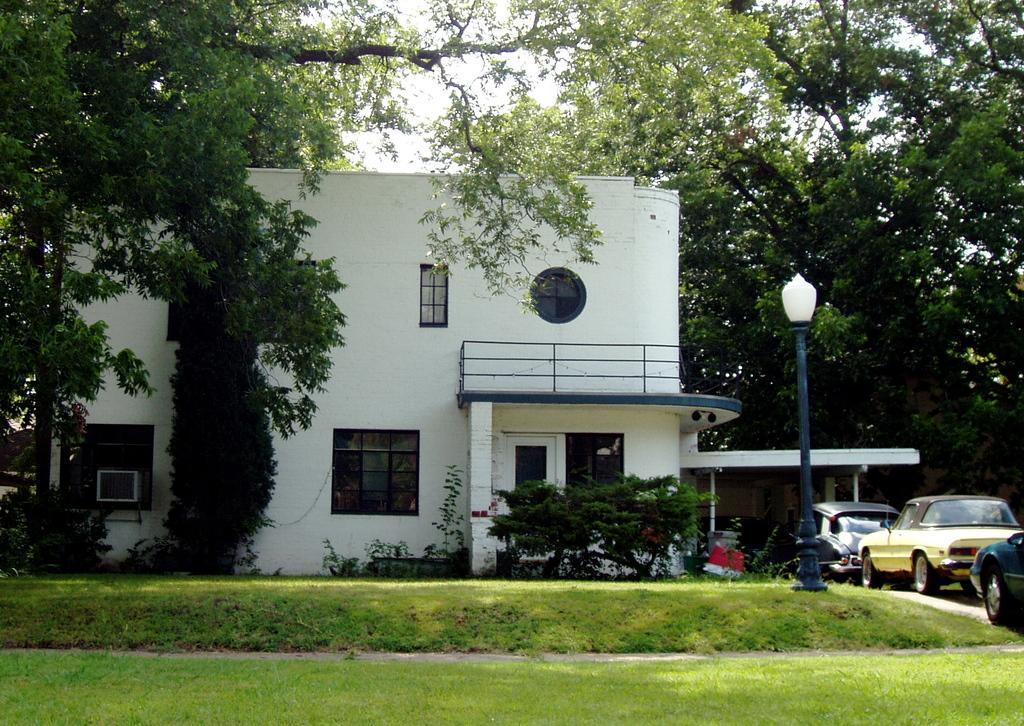Please provide a concise description of this image. In this image I can see few trees, building, windows, light pole, few vehicles and the green grass. The sky is in white color. 